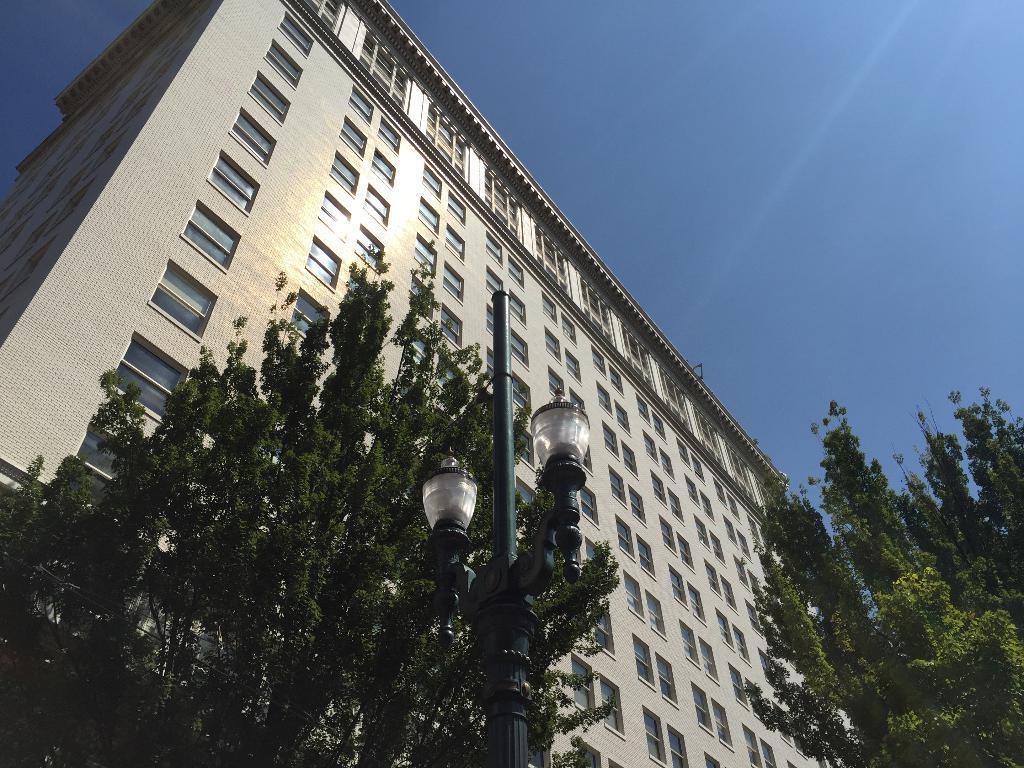Please provide a concise description of this image. Here we can see a building. There are trees, pole, and lights. In the background there is sky. 